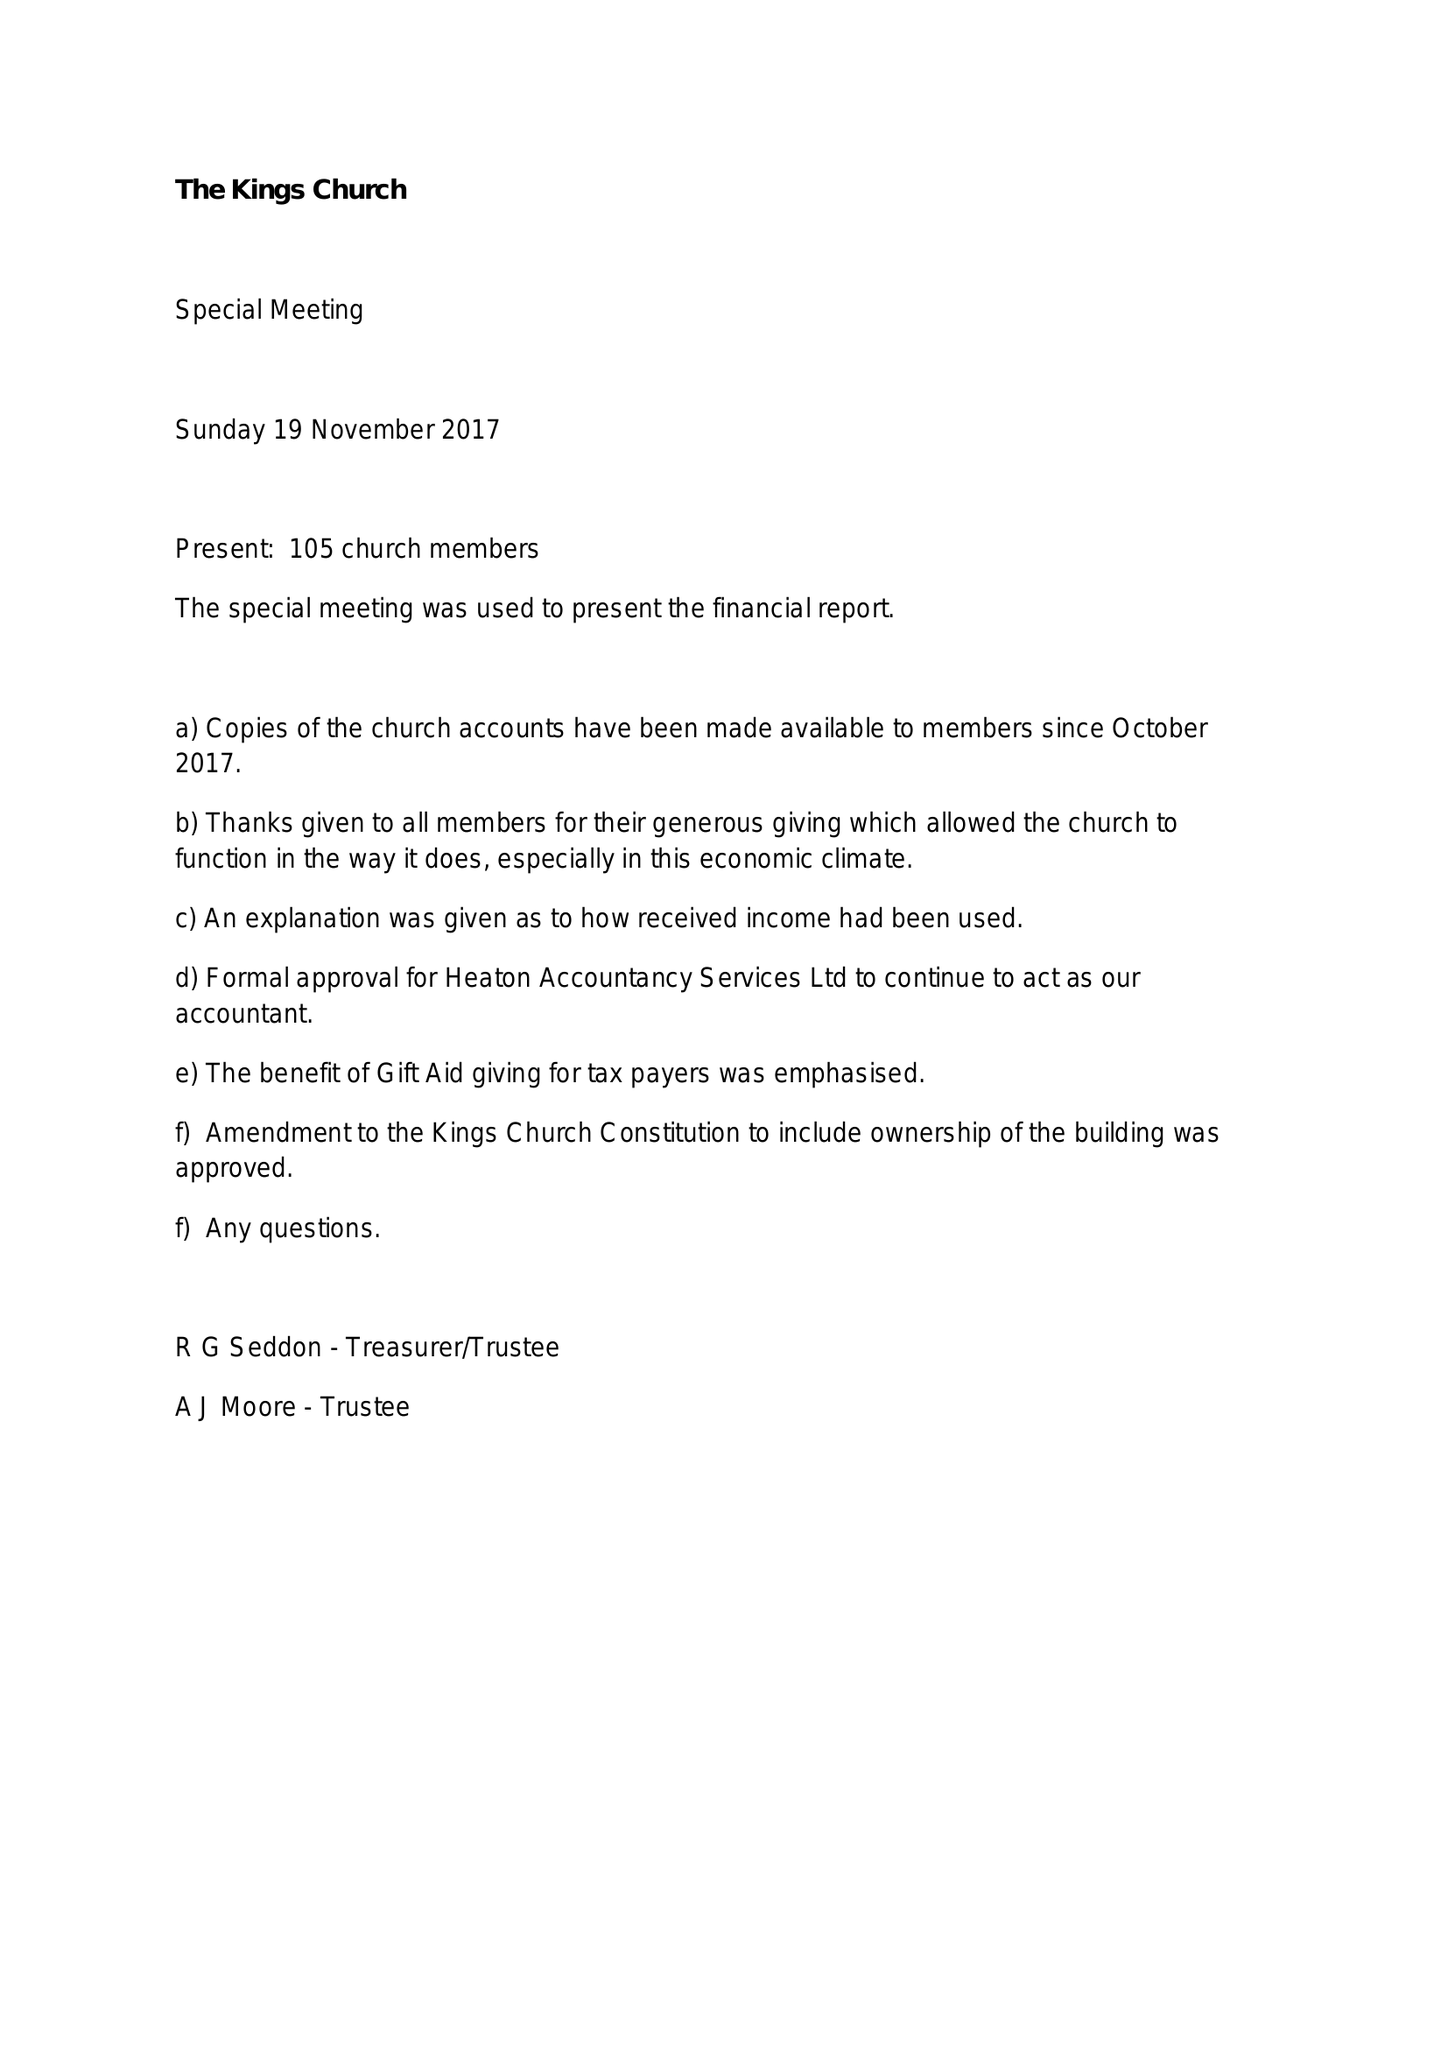What is the value for the charity_number?
Answer the question using a single word or phrase. 700457 